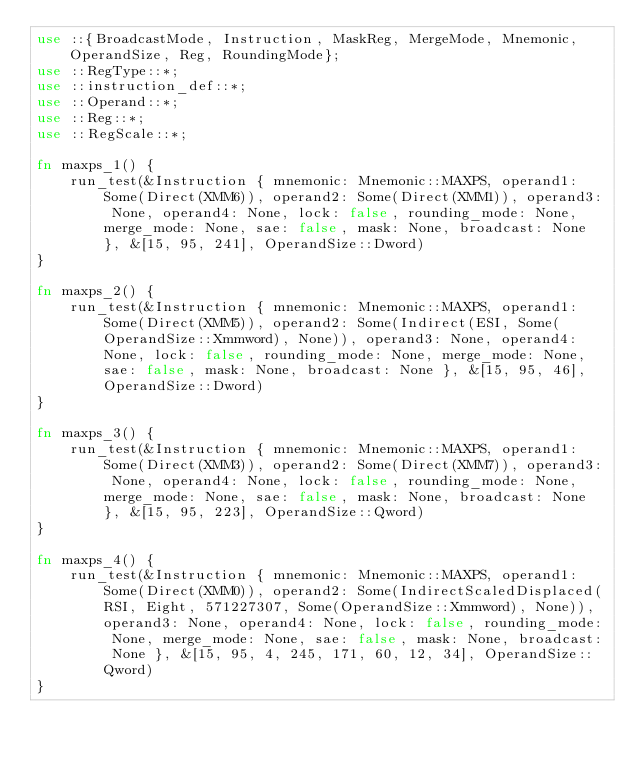<code> <loc_0><loc_0><loc_500><loc_500><_Rust_>use ::{BroadcastMode, Instruction, MaskReg, MergeMode, Mnemonic, OperandSize, Reg, RoundingMode};
use ::RegType::*;
use ::instruction_def::*;
use ::Operand::*;
use ::Reg::*;
use ::RegScale::*;

fn maxps_1() {
    run_test(&Instruction { mnemonic: Mnemonic::MAXPS, operand1: Some(Direct(XMM6)), operand2: Some(Direct(XMM1)), operand3: None, operand4: None, lock: false, rounding_mode: None, merge_mode: None, sae: false, mask: None, broadcast: None }, &[15, 95, 241], OperandSize::Dword)
}

fn maxps_2() {
    run_test(&Instruction { mnemonic: Mnemonic::MAXPS, operand1: Some(Direct(XMM5)), operand2: Some(Indirect(ESI, Some(OperandSize::Xmmword), None)), operand3: None, operand4: None, lock: false, rounding_mode: None, merge_mode: None, sae: false, mask: None, broadcast: None }, &[15, 95, 46], OperandSize::Dword)
}

fn maxps_3() {
    run_test(&Instruction { mnemonic: Mnemonic::MAXPS, operand1: Some(Direct(XMM3)), operand2: Some(Direct(XMM7)), operand3: None, operand4: None, lock: false, rounding_mode: None, merge_mode: None, sae: false, mask: None, broadcast: None }, &[15, 95, 223], OperandSize::Qword)
}

fn maxps_4() {
    run_test(&Instruction { mnemonic: Mnemonic::MAXPS, operand1: Some(Direct(XMM0)), operand2: Some(IndirectScaledDisplaced(RSI, Eight, 571227307, Some(OperandSize::Xmmword), None)), operand3: None, operand4: None, lock: false, rounding_mode: None, merge_mode: None, sae: false, mask: None, broadcast: None }, &[15, 95, 4, 245, 171, 60, 12, 34], OperandSize::Qword)
}

</code> 